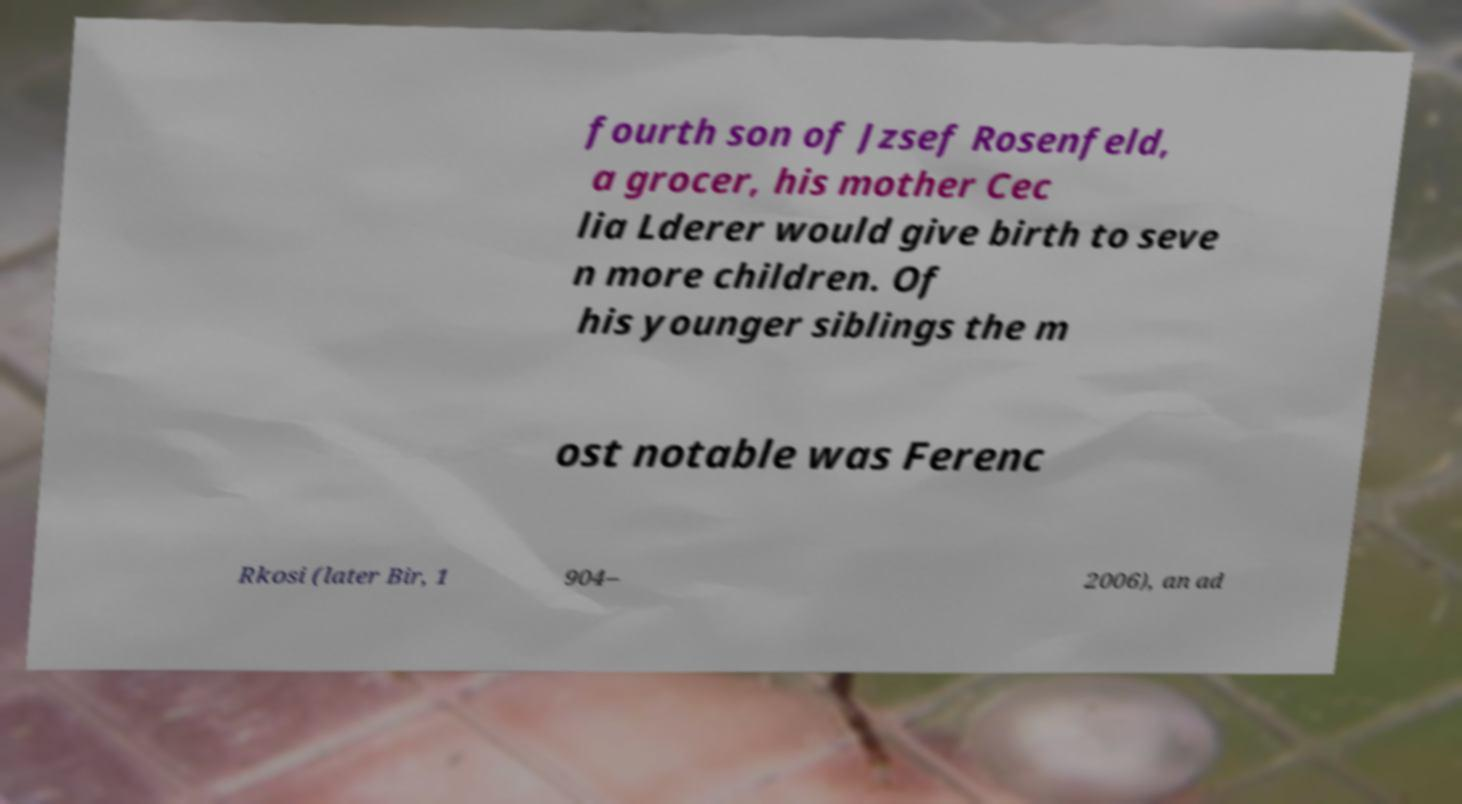Could you extract and type out the text from this image? fourth son of Jzsef Rosenfeld, a grocer, his mother Cec lia Lderer would give birth to seve n more children. Of his younger siblings the m ost notable was Ferenc Rkosi (later Bir, 1 904– 2006), an ad 